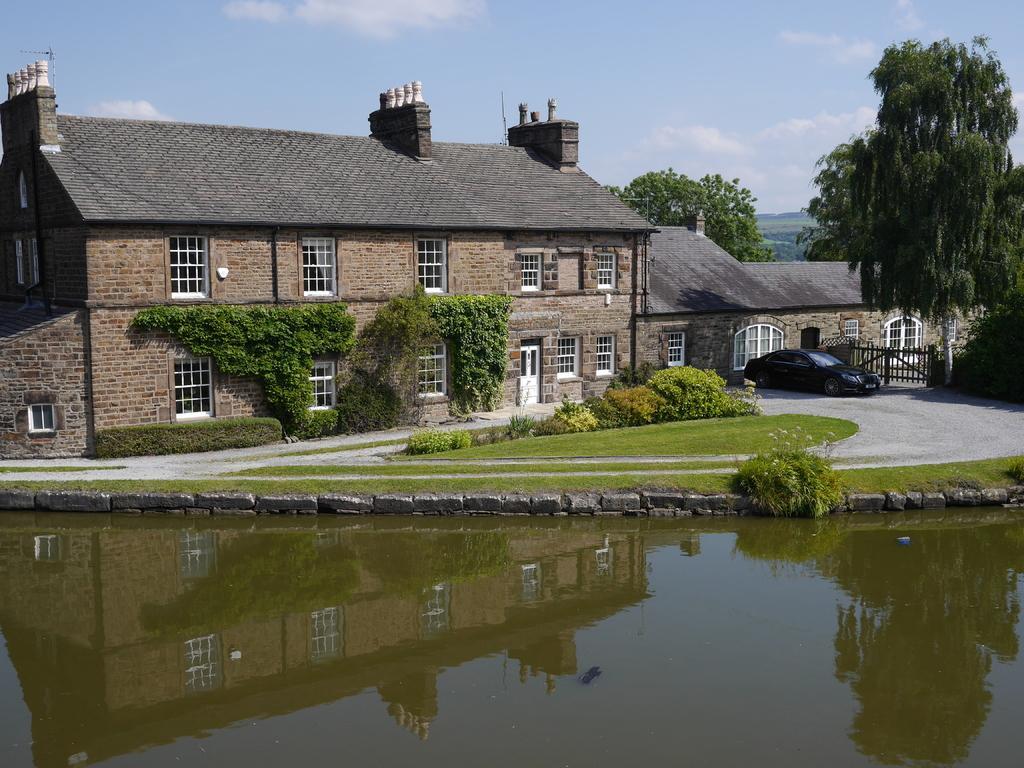In one or two sentences, can you explain what this image depicts? In this image, we can see some plants and trees. There is a building in the middle of the image. There is a lake at the bottom of the image. There is a car in front of the gate. There is a sky at the top of the image. 